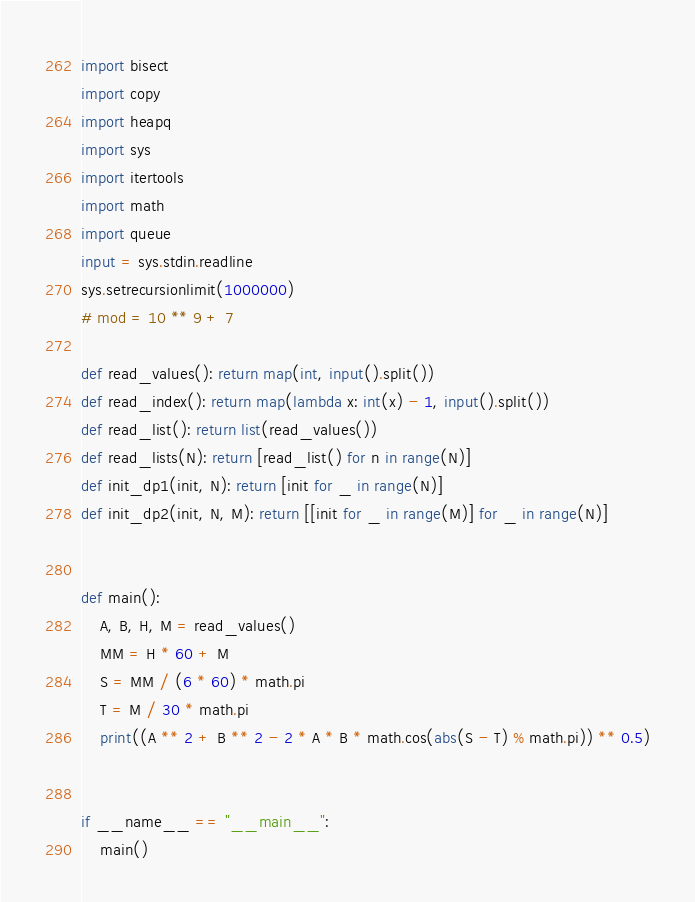Convert code to text. <code><loc_0><loc_0><loc_500><loc_500><_Python_>import bisect
import copy
import heapq
import sys
import itertools
import math
import queue
input = sys.stdin.readline
sys.setrecursionlimit(1000000)
# mod = 10 ** 9 + 7

def read_values(): return map(int, input().split())
def read_index(): return map(lambda x: int(x) - 1, input().split())
def read_list(): return list(read_values())
def read_lists(N): return [read_list() for n in range(N)]
def init_dp1(init, N): return [init for _ in range(N)]
def init_dp2(init, N, M): return [[init for _ in range(M)] for _ in range(N)]


def main():
    A, B, H, M = read_values()
    MM = H * 60 + M
    S = MM / (6 * 60) * math.pi
    T = M / 30 * math.pi
    print((A ** 2 + B ** 2 - 2 * A * B * math.cos(abs(S - T) % math.pi)) ** 0.5)


if __name__ == "__main__":
    main()

</code> 